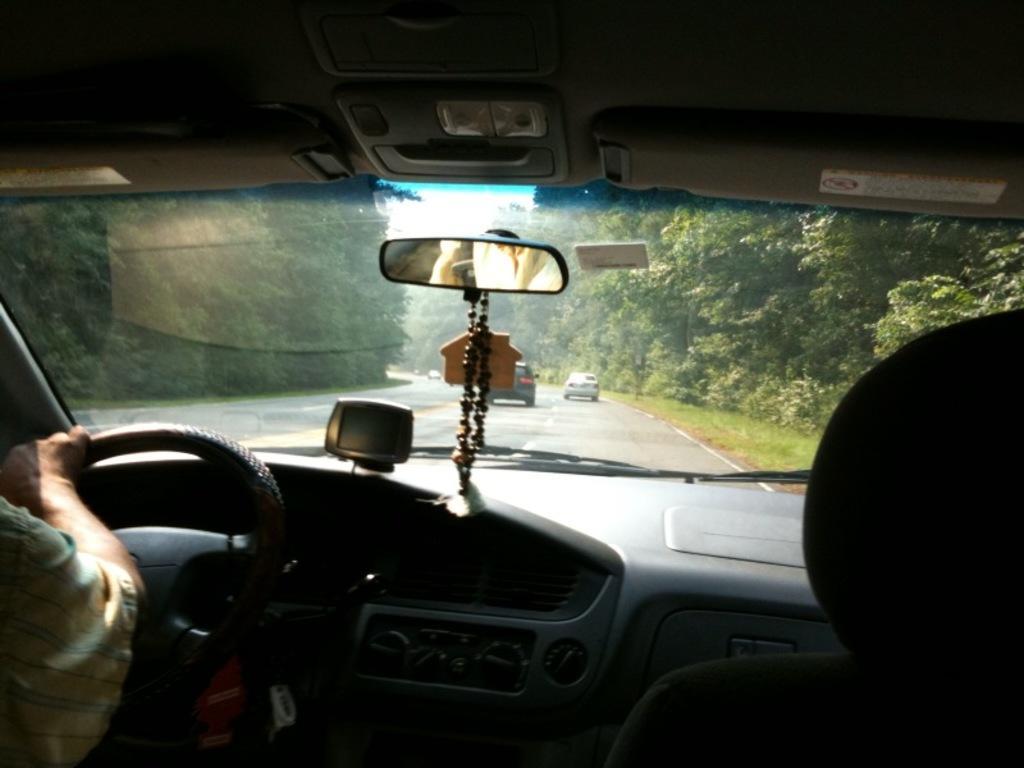How would you summarize this image in a sentence or two? The image is taken from inside a vehicle, there is a person sitting in front of the steering and outside the vehicle there are some other cars moving on the road, the road is surrounded with plenty of trees. 